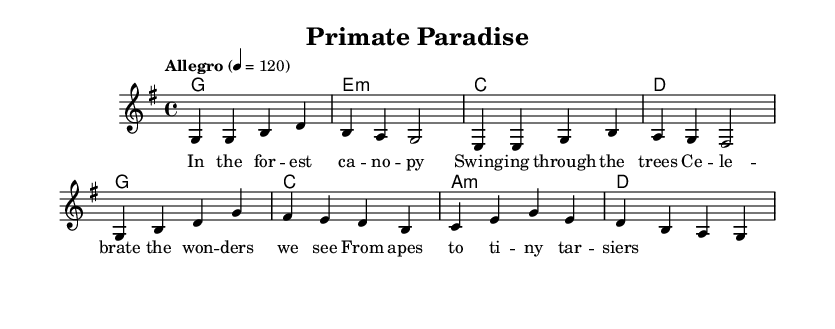What is the key signature of this music? The key signature is G major, which has one sharp (F sharp). It can be identified by looking at the beginning of the staff where the sharps are indicated.
Answer: G major What is the time signature of this music? The time signature is 4/4, denoting four beats per measure, which is commonly reflected by the "4" on the top and the "4" on the bottom of the time signature indicator.
Answer: 4/4 What is the tempo marking? The tempo marking is "Allegro," indicating a fast, lively tempo. The number 120 indicates the beats per minute, which provides specific performance guidance.
Answer: Allegro How many measures are in the verse section? The verse section consists of four measures, which can be counted by identifying the groupings of beats and the corresponding notation for each line of the melody.
Answer: 4 measures What chords are played during the chorus? The chords during the chorus are G, C, A minor, and D, which can be determined by looking at the chord names written above the melody and identifying their corresponding sequences.
Answer: G, C, A minor, D What is the lyrical theme of the song? The lyrical theme revolves around celebrating the wonders of biodiversity and the natural world, as indicated by the words "Celebrate the wonders we see" within the lyrics provided for the chorus.
Answer: Celebrating biodiversity How many lines of lyrics are associated with the melody? There are two lines of lyrics associated with the melody, one for the verse and one for the chorus, which can be counted by looking at the separate lyric lines represented in the music.
Answer: 2 lines 